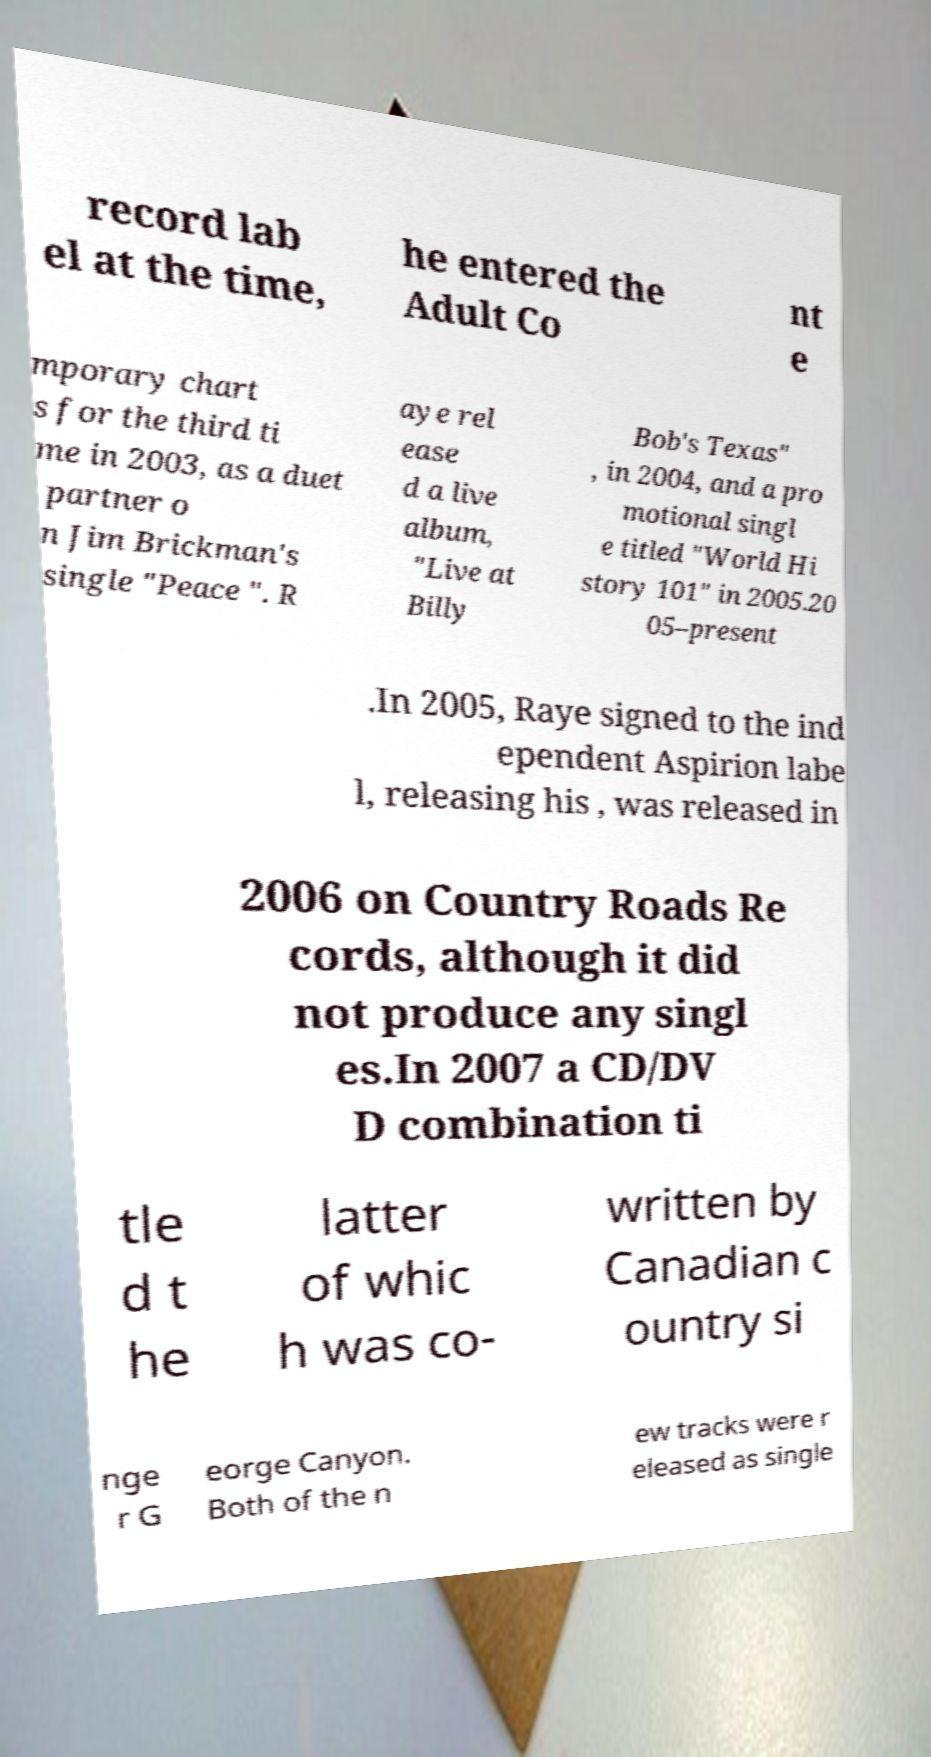Please read and relay the text visible in this image. What does it say? record lab el at the time, he entered the Adult Co nt e mporary chart s for the third ti me in 2003, as a duet partner o n Jim Brickman's single "Peace ". R aye rel ease d a live album, "Live at Billy Bob's Texas" , in 2004, and a pro motional singl e titled "World Hi story 101" in 2005.20 05–present .In 2005, Raye signed to the ind ependent Aspirion labe l, releasing his , was released in 2006 on Country Roads Re cords, although it did not produce any singl es.In 2007 a CD/DV D combination ti tle d t he latter of whic h was co- written by Canadian c ountry si nge r G eorge Canyon. Both of the n ew tracks were r eleased as single 